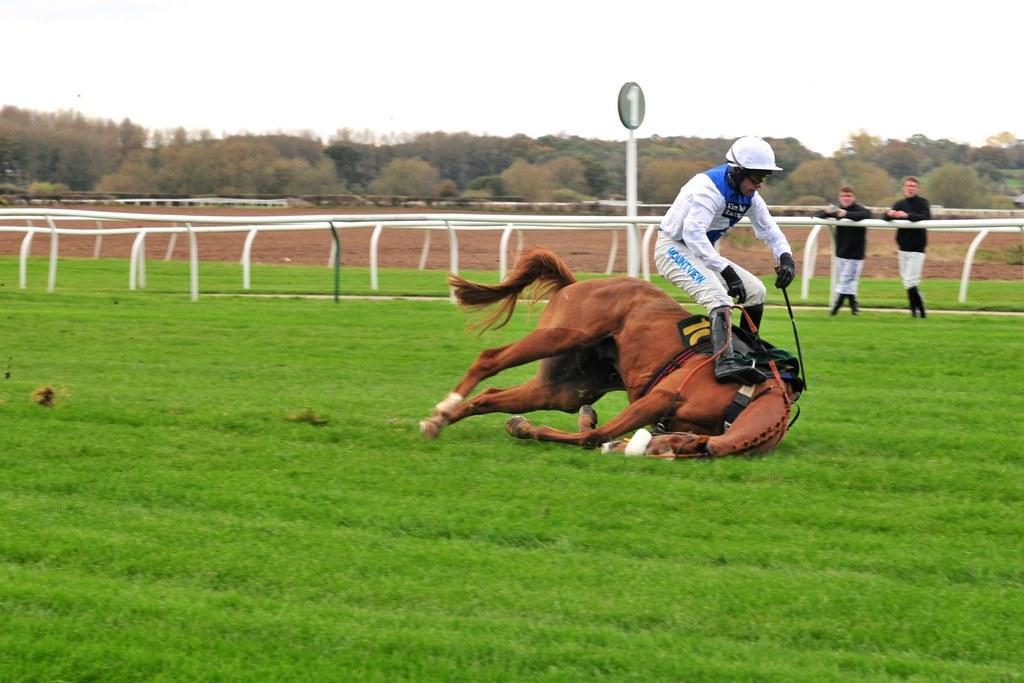Could you give a brief overview of what you see in this image? There is a man and a horse, it seems like he is about to fall on the grassland in the foreground area of the image, there are people, boundary, trees and the sky in the background. 